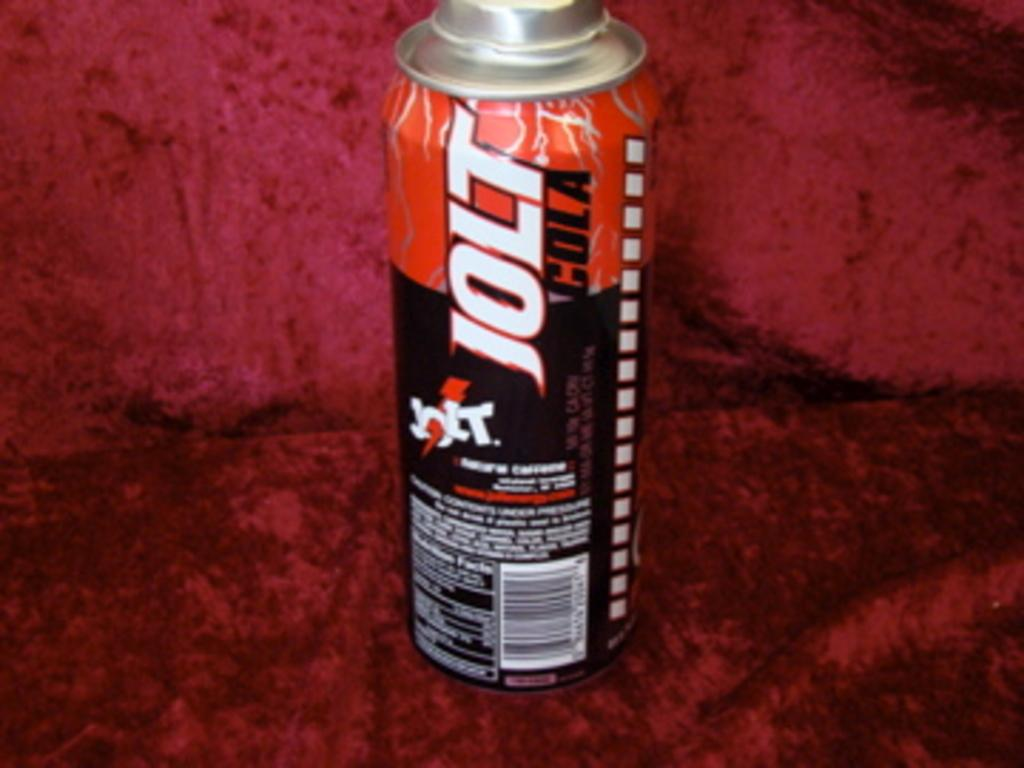<image>
Render a clear and concise summary of the photo. Jolt Cola is the name shown on the can of this energy drink. 